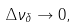Convert formula to latex. <formula><loc_0><loc_0><loc_500><loc_500>\Delta \nu _ { \delta } \rightarrow 0 ,</formula> 